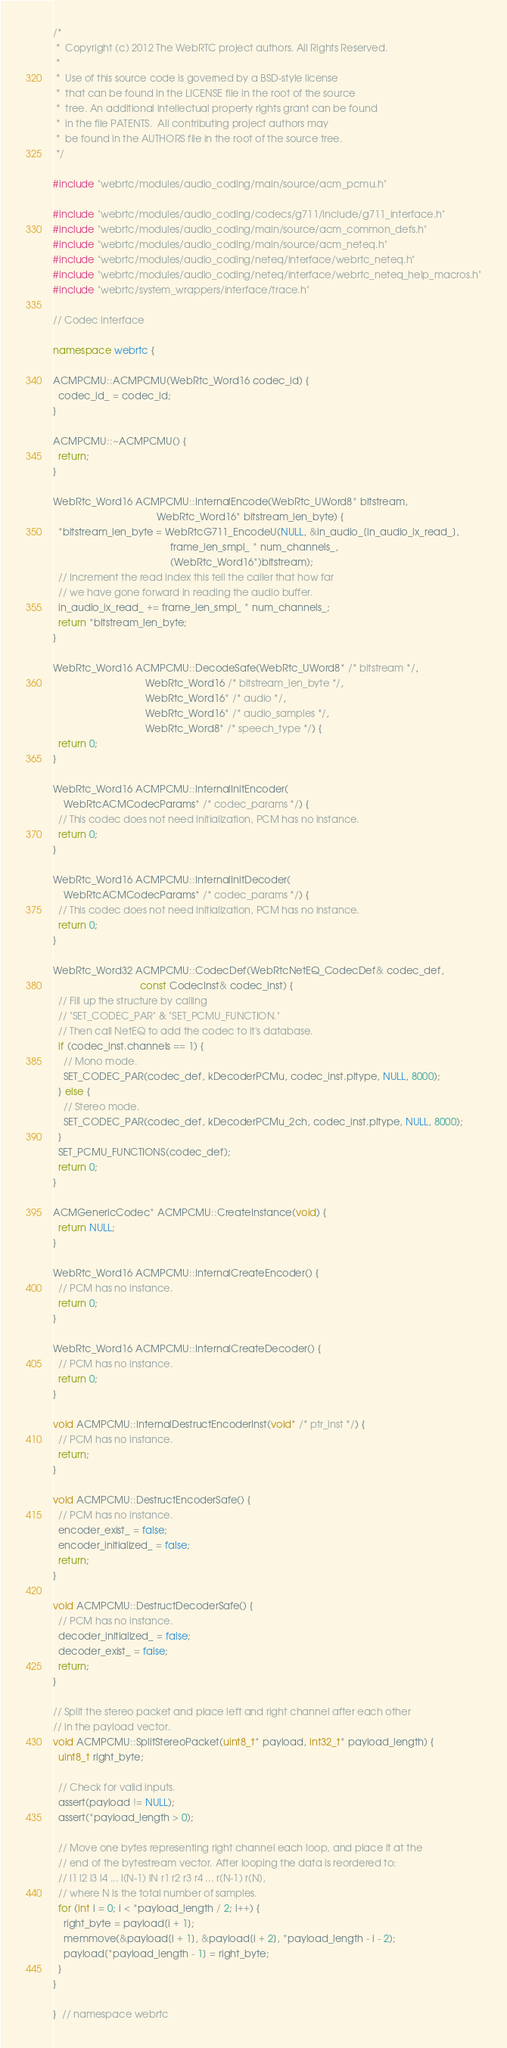<code> <loc_0><loc_0><loc_500><loc_500><_C++_>/*
 *  Copyright (c) 2012 The WebRTC project authors. All Rights Reserved.
 *
 *  Use of this source code is governed by a BSD-style license
 *  that can be found in the LICENSE file in the root of the source
 *  tree. An additional intellectual property rights grant can be found
 *  in the file PATENTS.  All contributing project authors may
 *  be found in the AUTHORS file in the root of the source tree.
 */

#include "webrtc/modules/audio_coding/main/source/acm_pcmu.h"

#include "webrtc/modules/audio_coding/codecs/g711/include/g711_interface.h"
#include "webrtc/modules/audio_coding/main/source/acm_common_defs.h"
#include "webrtc/modules/audio_coding/main/source/acm_neteq.h"
#include "webrtc/modules/audio_coding/neteq/interface/webrtc_neteq.h"
#include "webrtc/modules/audio_coding/neteq/interface/webrtc_neteq_help_macros.h"
#include "webrtc/system_wrappers/interface/trace.h"

// Codec interface

namespace webrtc {

ACMPCMU::ACMPCMU(WebRtc_Word16 codec_id) {
  codec_id_ = codec_id;
}

ACMPCMU::~ACMPCMU() {
  return;
}

WebRtc_Word16 ACMPCMU::InternalEncode(WebRtc_UWord8* bitstream,
                                      WebRtc_Word16* bitstream_len_byte) {
  *bitstream_len_byte = WebRtcG711_EncodeU(NULL, &in_audio_[in_audio_ix_read_],
                                           frame_len_smpl_ * num_channels_,
                                           (WebRtc_Word16*)bitstream);
  // Increment the read index this tell the caller that how far
  // we have gone forward in reading the audio buffer.
  in_audio_ix_read_ += frame_len_smpl_ * num_channels_;
  return *bitstream_len_byte;
}

WebRtc_Word16 ACMPCMU::DecodeSafe(WebRtc_UWord8* /* bitstream */,
                                  WebRtc_Word16 /* bitstream_len_byte */,
                                  WebRtc_Word16* /* audio */,
                                  WebRtc_Word16* /* audio_samples */,
                                  WebRtc_Word8* /* speech_type */) {
  return 0;
}

WebRtc_Word16 ACMPCMU::InternalInitEncoder(
    WebRtcACMCodecParams* /* codec_params */) {
  // This codec does not need initialization, PCM has no instance.
  return 0;
}

WebRtc_Word16 ACMPCMU::InternalInitDecoder(
    WebRtcACMCodecParams* /* codec_params */) {
  // This codec does not need initialization, PCM has no instance.
  return 0;
}

WebRtc_Word32 ACMPCMU::CodecDef(WebRtcNetEQ_CodecDef& codec_def,
                                const CodecInst& codec_inst) {
  // Fill up the structure by calling
  // "SET_CODEC_PAR" & "SET_PCMU_FUNCTION."
  // Then call NetEQ to add the codec to it's database.
  if (codec_inst.channels == 1) {
    // Mono mode.
    SET_CODEC_PAR(codec_def, kDecoderPCMu, codec_inst.pltype, NULL, 8000);
  } else {
    // Stereo mode.
    SET_CODEC_PAR(codec_def, kDecoderPCMu_2ch, codec_inst.pltype, NULL, 8000);
  }
  SET_PCMU_FUNCTIONS(codec_def);
  return 0;
}

ACMGenericCodec* ACMPCMU::CreateInstance(void) {
  return NULL;
}

WebRtc_Word16 ACMPCMU::InternalCreateEncoder() {
  // PCM has no instance.
  return 0;
}

WebRtc_Word16 ACMPCMU::InternalCreateDecoder() {
  // PCM has no instance.
  return 0;
}

void ACMPCMU::InternalDestructEncoderInst(void* /* ptr_inst */) {
  // PCM has no instance.
  return;
}

void ACMPCMU::DestructEncoderSafe() {
  // PCM has no instance.
  encoder_exist_ = false;
  encoder_initialized_ = false;
  return;
}

void ACMPCMU::DestructDecoderSafe() {
  // PCM has no instance.
  decoder_initialized_ = false;
  decoder_exist_ = false;
  return;
}

// Split the stereo packet and place left and right channel after each other
// in the payload vector.
void ACMPCMU::SplitStereoPacket(uint8_t* payload, int32_t* payload_length) {
  uint8_t right_byte;

  // Check for valid inputs.
  assert(payload != NULL);
  assert(*payload_length > 0);

  // Move one bytes representing right channel each loop, and place it at the
  // end of the bytestream vector. After looping the data is reordered to:
  // l1 l2 l3 l4 ... l(N-1) lN r1 r2 r3 r4 ... r(N-1) r(N),
  // where N is the total number of samples.
  for (int i = 0; i < *payload_length / 2; i++) {
    right_byte = payload[i + 1];
    memmove(&payload[i + 1], &payload[i + 2], *payload_length - i - 2);
    payload[*payload_length - 1] = right_byte;
  }
}

}  // namespace webrtc
</code> 